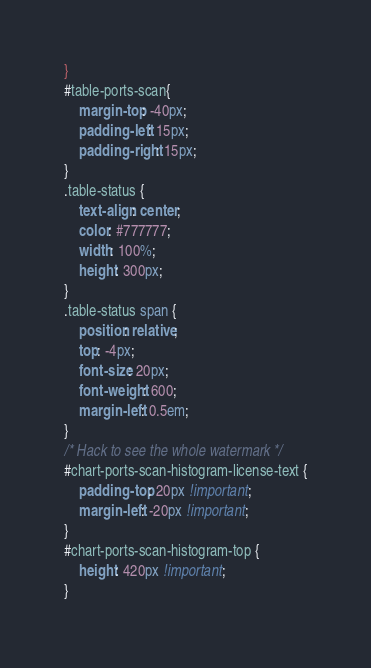Convert code to text. <code><loc_0><loc_0><loc_500><loc_500><_CSS_>}
#table-ports-scan{
    margin-top: -40px;
    padding-left: 15px;
    padding-right: 15px;
}
.table-status {
    text-align: center;
    color: #777777;
    width: 100%;
    height: 300px;
}
.table-status span {
    position: relative;
    top: -4px;
    font-size: 20px;
    font-weight: 600;
    margin-left: 0.5em;
}
/* Hack to see the whole watermark */
#chart-ports-scan-histogram-license-text {
    padding-top: 20px !important;
    margin-left: -20px !important;
}
#chart-ports-scan-histogram-top {
    height: 420px !important;
}</code> 